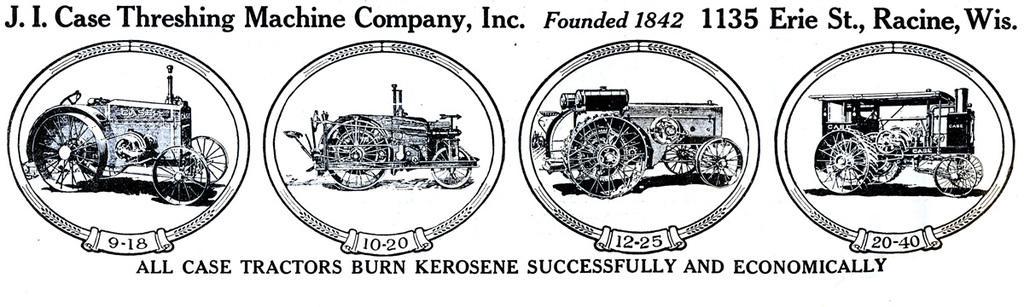Could you give a brief overview of what you see in this image? In this picture we can see the sketches of the tractors and we can see the numbers and the text on the image. 